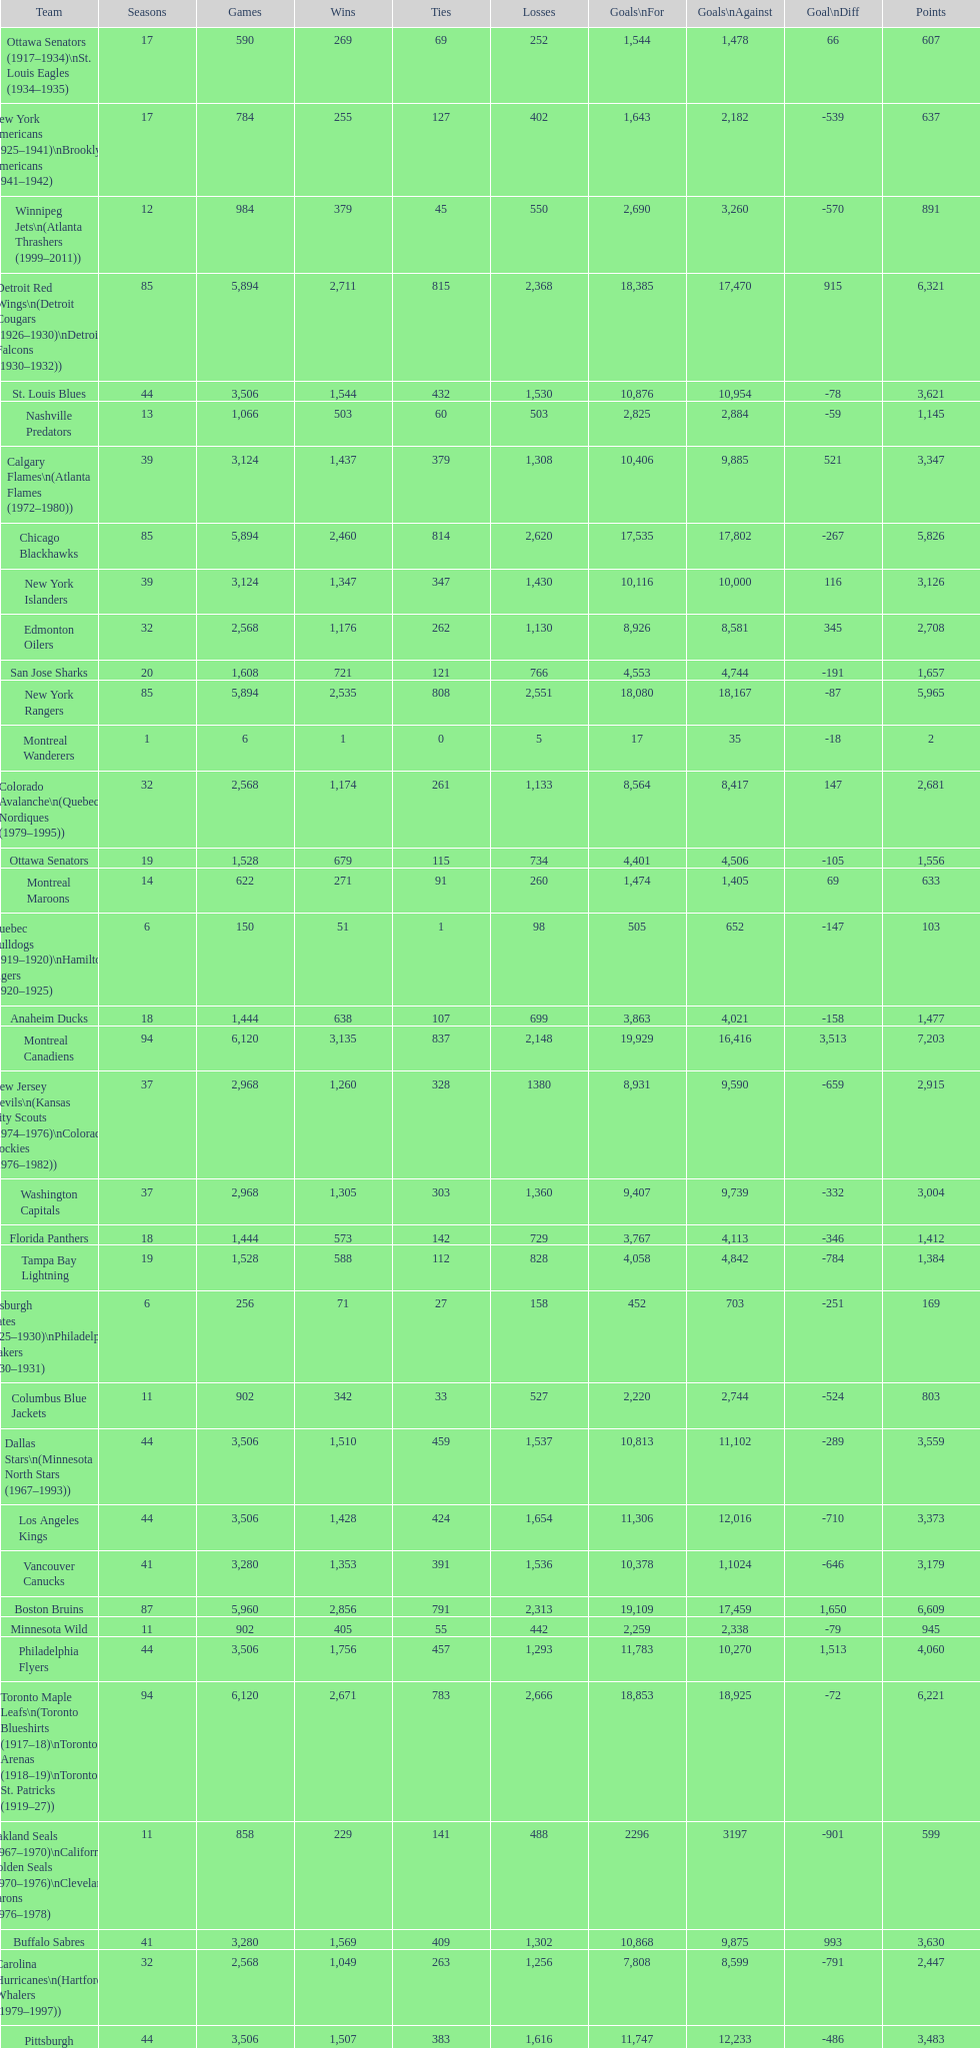What is the number of games that the vancouver canucks have won up to this point? 1,353. 